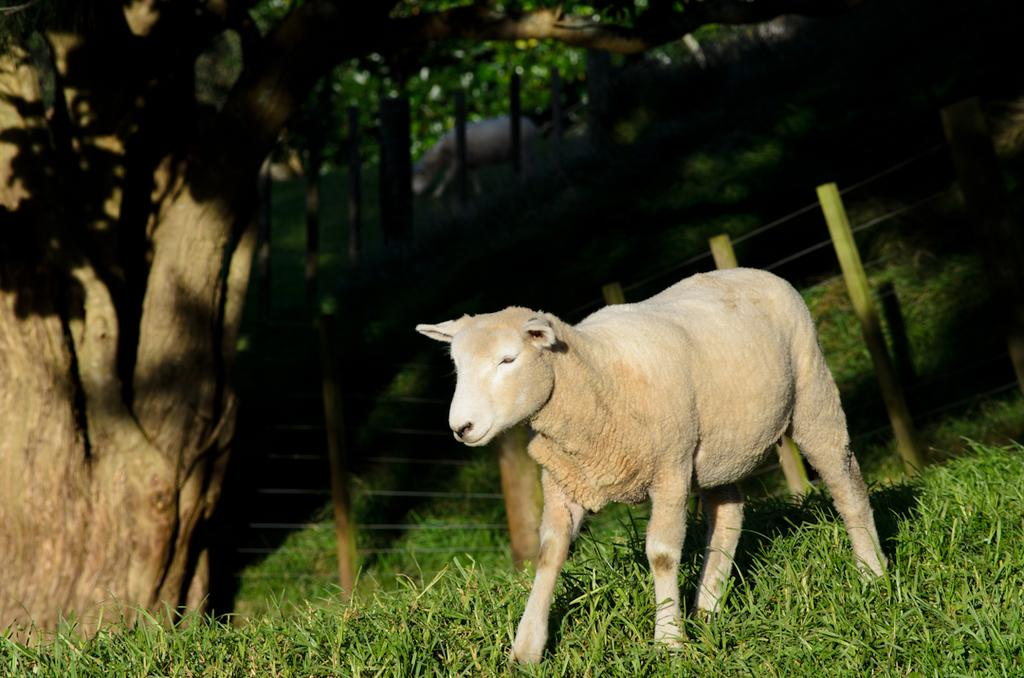What types of living organisms can be seen in the image? There are animals in the image. What natural elements are present in the image? There are trees, grass, and poles in the image. What type of barrier can be seen in the image? There is a fence in the image. What type of lace can be seen on the animals in the image? There is no lace present on the animals in the image. Can you tell me how many ladybugs are sitting on the fence in the image? There are no ladybugs present in the image. 